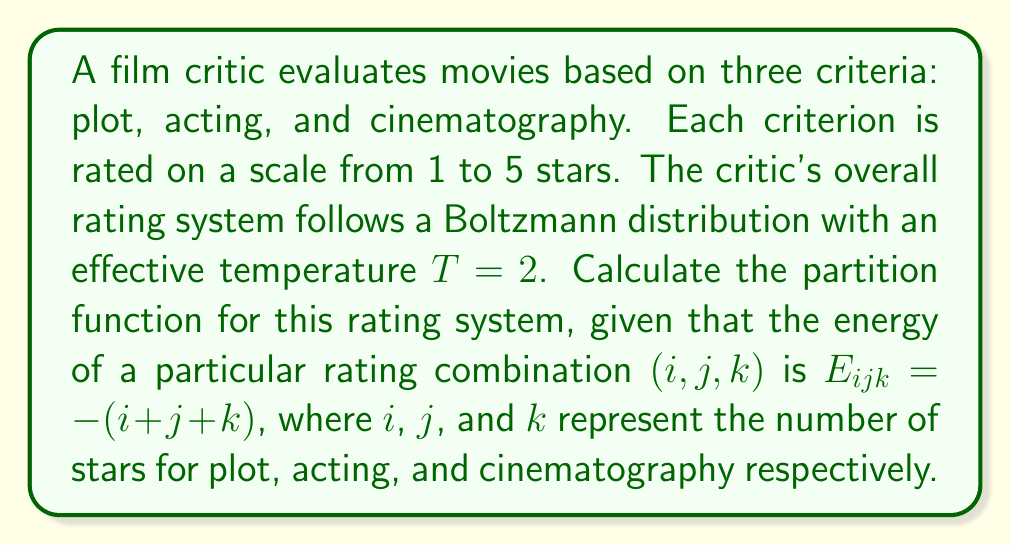Teach me how to tackle this problem. To solve this problem, we'll follow these steps:

1) The partition function $Z$ is defined as the sum over all possible states of the Boltzmann factor:

   $$Z = \sum_{\text{all states}} e^{-\beta E}$$

   where $\beta = \frac{1}{k_B T}$, and $k_B$ is Boltzmann's constant (which we'll set to 1 for simplicity).

2) In this case, $\beta = \frac{1}{T} = \frac{1}{2}$, and $E_{ijk} = -(i + j + k)$.

3) We need to sum over all possible combinations of $i$, $j$, and $k$, each ranging from 1 to 5:

   $$Z = \sum_{i=1}^5 \sum_{j=1}^5 \sum_{k=1}^5 e^{-\frac{1}{2}E_{ijk}}$$

4) Substituting the energy function:

   $$Z = \sum_{i=1}^5 \sum_{j=1}^5 \sum_{k=1}^5 e^{\frac{1}{2}(i + j + k)}$$

5) This can be rewritten as:

   $$Z = \left(\sum_{i=1}^5 e^{\frac{i}{2}}\right) \left(\sum_{j=1}^5 e^{\frac{j}{2}}\right) \left(\sum_{k=1}^5 e^{\frac{k}{2}}\right)$$

6) Each sum is identical, so we can cube a single sum:

   $$Z = \left(\sum_{n=1}^5 e^{\frac{n}{2}}\right)^3$$

7) Evaluating the sum:

   $$\sum_{n=1}^5 e^{\frac{n}{2}} = e^{\frac{1}{2}} + e^{1} + e^{\frac{3}{2}} + e^{2} + e^{\frac{5}{2}}$$

8) Calculate this sum and cube the result:

   $$Z = (1.6487 + 2.7183 + 4.4817 + 7.3891 + 12.1825)^3$$
   $$Z = 28.4203^3 = 22937.0729$$
Answer: 22937.0729 